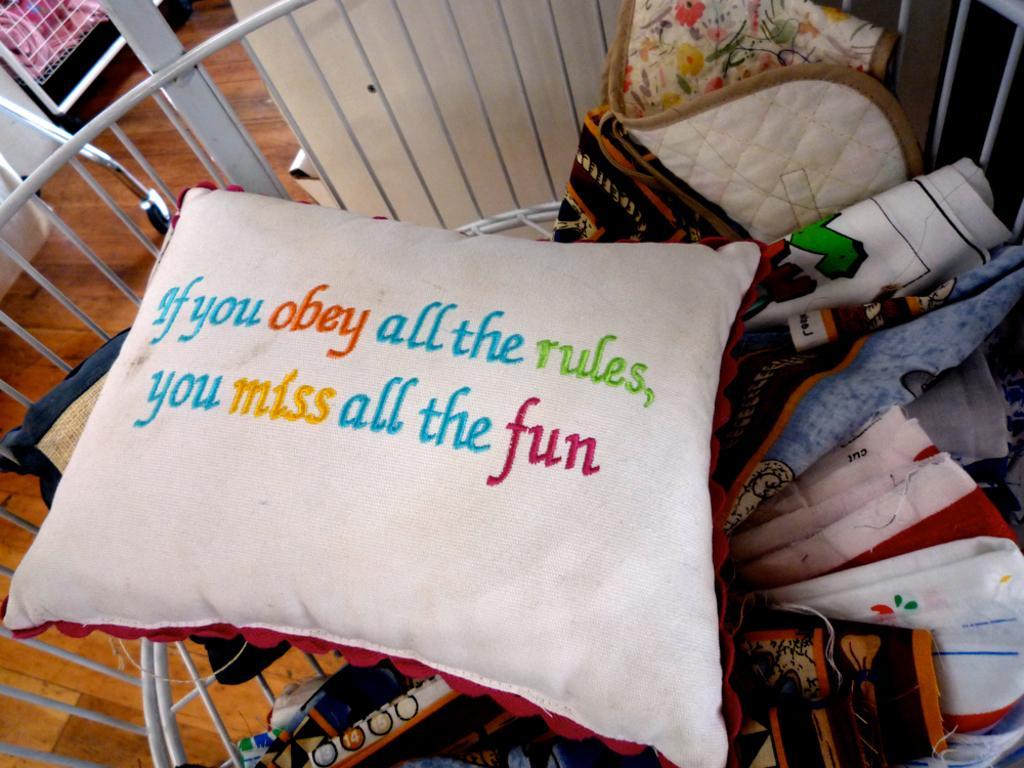Please provide a concise description of this image. In this image, we can see a pillow and some clothes in a white colored object. We can see the wooden surface. We can also see some objects on the left. 